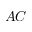<formula> <loc_0><loc_0><loc_500><loc_500>A C</formula> 